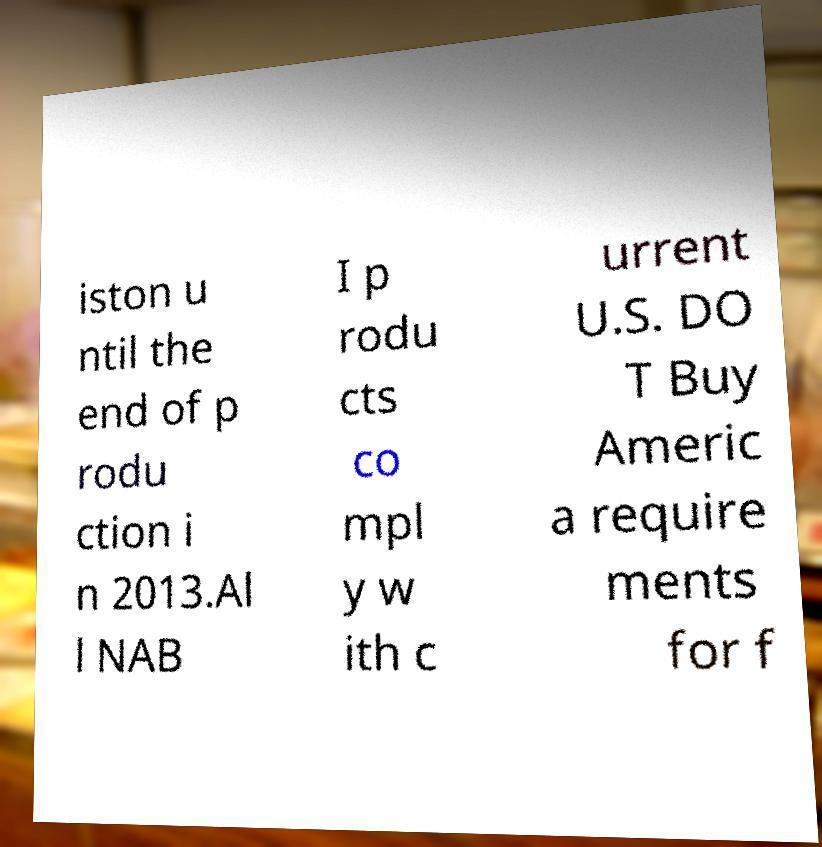Please read and relay the text visible in this image. What does it say? iston u ntil the end of p rodu ction i n 2013.Al l NAB I p rodu cts co mpl y w ith c urrent U.S. DO T Buy Americ a require ments for f 